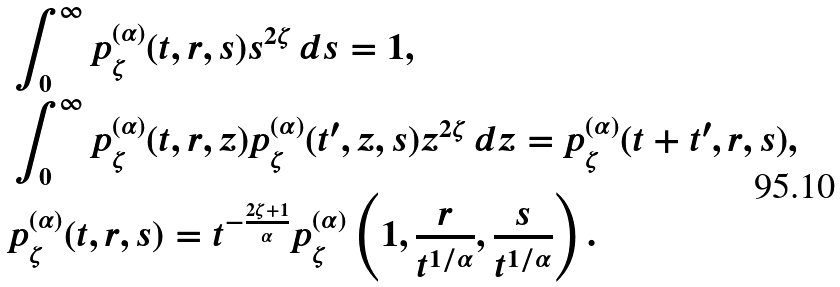Convert formula to latex. <formula><loc_0><loc_0><loc_500><loc_500>& \int _ { 0 } ^ { \infty } p _ { \zeta } ^ { ( \alpha ) } ( t , r , s ) s ^ { 2 \zeta } \, d s = 1 , \\ & \int _ { 0 } ^ { \infty } p _ { \zeta } ^ { ( \alpha ) } ( t , r , z ) p _ { \zeta } ^ { ( \alpha ) } ( t ^ { \prime } , z , s ) z ^ { 2 \zeta } \, d z = p _ { \zeta } ^ { ( \alpha ) } ( t + t ^ { \prime } , r , s ) , \\ & p _ { \zeta } ^ { ( \alpha ) } ( t , r , s ) = t ^ { - \frac { 2 \zeta + 1 } { \alpha } } p _ { \zeta } ^ { ( \alpha ) } \left ( 1 , \frac { r } { t ^ { 1 / \alpha } } , \frac { s } { t ^ { 1 / \alpha } } \right ) .</formula> 